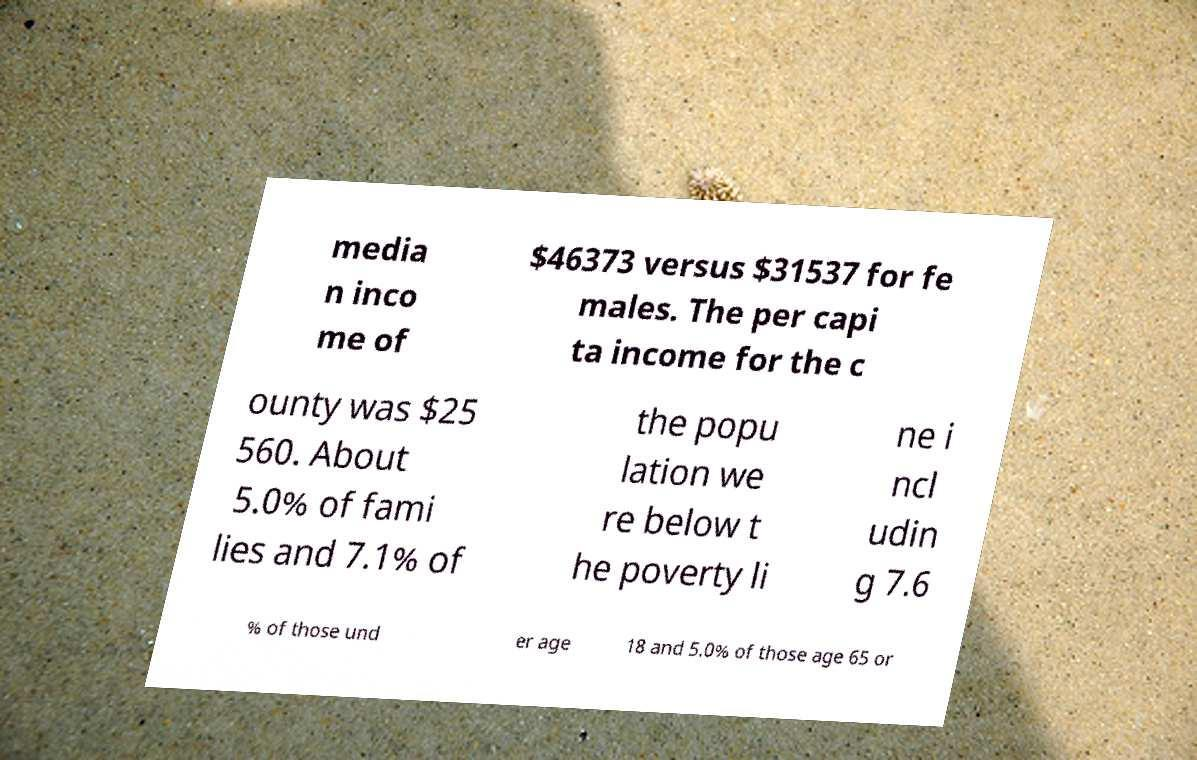For documentation purposes, I need the text within this image transcribed. Could you provide that? media n inco me of $46373 versus $31537 for fe males. The per capi ta income for the c ounty was $25 560. About 5.0% of fami lies and 7.1% of the popu lation we re below t he poverty li ne i ncl udin g 7.6 % of those und er age 18 and 5.0% of those age 65 or 